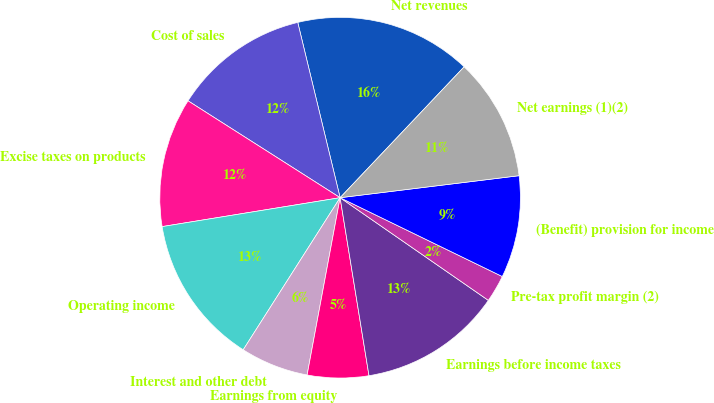Convert chart to OTSL. <chart><loc_0><loc_0><loc_500><loc_500><pie_chart><fcel>Net revenues<fcel>Cost of sales<fcel>Excise taxes on products<fcel>Operating income<fcel>Interest and other debt<fcel>Earnings from equity<fcel>Earnings before income taxes<fcel>Pre-tax profit margin (2)<fcel>(Benefit) provision for income<fcel>Net earnings (1)(2)<nl><fcel>15.85%<fcel>12.2%<fcel>11.59%<fcel>13.41%<fcel>6.1%<fcel>5.49%<fcel>12.8%<fcel>2.44%<fcel>9.15%<fcel>10.98%<nl></chart> 